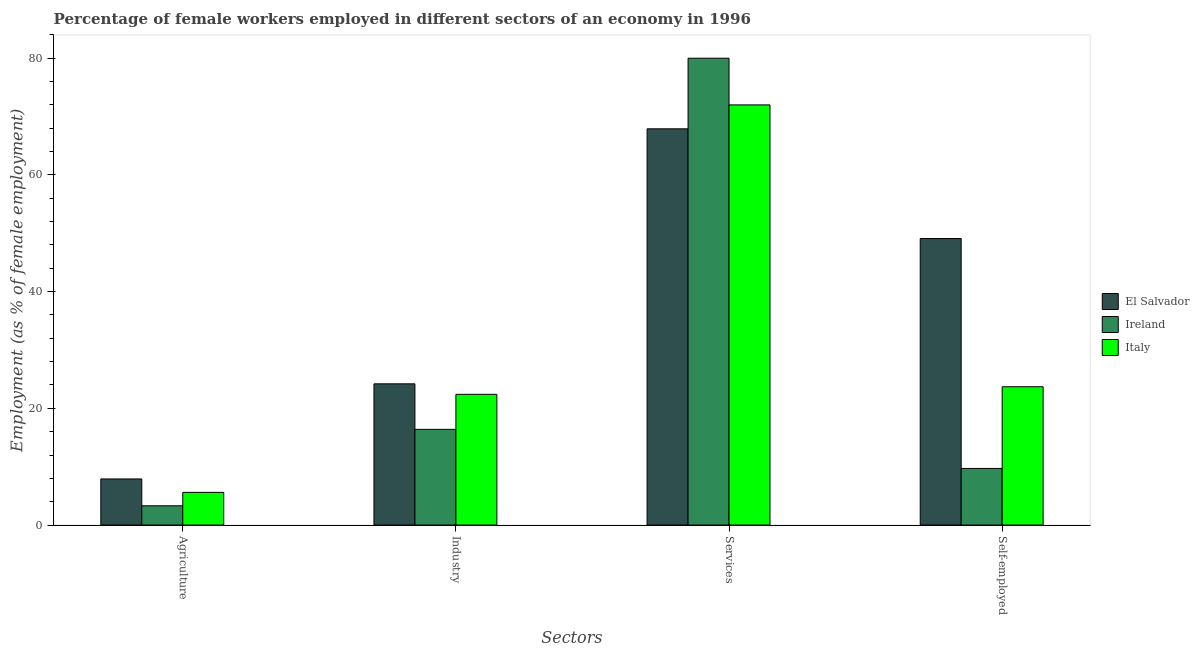How many different coloured bars are there?
Ensure brevity in your answer.  3. How many groups of bars are there?
Keep it short and to the point. 4. Are the number of bars per tick equal to the number of legend labels?
Your answer should be compact. Yes. How many bars are there on the 4th tick from the right?
Give a very brief answer. 3. What is the label of the 3rd group of bars from the left?
Your answer should be very brief. Services. What is the percentage of female workers in industry in Ireland?
Provide a succinct answer. 16.4. Across all countries, what is the maximum percentage of female workers in industry?
Your response must be concise. 24.2. Across all countries, what is the minimum percentage of female workers in services?
Provide a succinct answer. 67.9. In which country was the percentage of self employed female workers maximum?
Make the answer very short. El Salvador. In which country was the percentage of self employed female workers minimum?
Ensure brevity in your answer.  Ireland. What is the total percentage of female workers in services in the graph?
Provide a succinct answer. 219.9. What is the difference between the percentage of self employed female workers in Ireland and that in Italy?
Offer a very short reply. -14. What is the difference between the percentage of female workers in agriculture in Ireland and the percentage of self employed female workers in El Salvador?
Keep it short and to the point. -45.8. What is the average percentage of female workers in agriculture per country?
Your answer should be compact. 5.6. What is the difference between the percentage of female workers in agriculture and percentage of self employed female workers in El Salvador?
Keep it short and to the point. -41.2. What is the ratio of the percentage of self employed female workers in Ireland to that in El Salvador?
Keep it short and to the point. 0.2. Is the percentage of female workers in agriculture in Ireland less than that in Italy?
Your answer should be very brief. Yes. What is the difference between the highest and the second highest percentage of female workers in agriculture?
Provide a short and direct response. 2.3. What is the difference between the highest and the lowest percentage of female workers in agriculture?
Give a very brief answer. 4.6. Is the sum of the percentage of self employed female workers in Italy and El Salvador greater than the maximum percentage of female workers in industry across all countries?
Give a very brief answer. Yes. Is it the case that in every country, the sum of the percentage of female workers in agriculture and percentage of female workers in services is greater than the sum of percentage of female workers in industry and percentage of self employed female workers?
Your answer should be very brief. Yes. What does the 2nd bar from the left in Industry represents?
Provide a succinct answer. Ireland. How many bars are there?
Make the answer very short. 12. Are all the bars in the graph horizontal?
Your answer should be very brief. No. How many countries are there in the graph?
Ensure brevity in your answer.  3. Does the graph contain grids?
Make the answer very short. No. Where does the legend appear in the graph?
Keep it short and to the point. Center right. How many legend labels are there?
Ensure brevity in your answer.  3. What is the title of the graph?
Your answer should be very brief. Percentage of female workers employed in different sectors of an economy in 1996. Does "Sao Tome and Principe" appear as one of the legend labels in the graph?
Keep it short and to the point. No. What is the label or title of the X-axis?
Offer a very short reply. Sectors. What is the label or title of the Y-axis?
Your answer should be compact. Employment (as % of female employment). What is the Employment (as % of female employment) of El Salvador in Agriculture?
Your answer should be compact. 7.9. What is the Employment (as % of female employment) of Ireland in Agriculture?
Offer a very short reply. 3.3. What is the Employment (as % of female employment) of Italy in Agriculture?
Keep it short and to the point. 5.6. What is the Employment (as % of female employment) in El Salvador in Industry?
Your answer should be very brief. 24.2. What is the Employment (as % of female employment) of Ireland in Industry?
Your answer should be very brief. 16.4. What is the Employment (as % of female employment) of Italy in Industry?
Offer a terse response. 22.4. What is the Employment (as % of female employment) of El Salvador in Services?
Your answer should be compact. 67.9. What is the Employment (as % of female employment) in Italy in Services?
Provide a succinct answer. 72. What is the Employment (as % of female employment) in El Salvador in Self-employed?
Your answer should be very brief. 49.1. What is the Employment (as % of female employment) in Ireland in Self-employed?
Provide a succinct answer. 9.7. What is the Employment (as % of female employment) in Italy in Self-employed?
Make the answer very short. 23.7. Across all Sectors, what is the maximum Employment (as % of female employment) of El Salvador?
Your answer should be very brief. 67.9. Across all Sectors, what is the maximum Employment (as % of female employment) of Italy?
Provide a succinct answer. 72. Across all Sectors, what is the minimum Employment (as % of female employment) of El Salvador?
Give a very brief answer. 7.9. Across all Sectors, what is the minimum Employment (as % of female employment) of Ireland?
Ensure brevity in your answer.  3.3. Across all Sectors, what is the minimum Employment (as % of female employment) in Italy?
Provide a short and direct response. 5.6. What is the total Employment (as % of female employment) of El Salvador in the graph?
Keep it short and to the point. 149.1. What is the total Employment (as % of female employment) in Ireland in the graph?
Give a very brief answer. 109.4. What is the total Employment (as % of female employment) of Italy in the graph?
Offer a very short reply. 123.7. What is the difference between the Employment (as % of female employment) of El Salvador in Agriculture and that in Industry?
Offer a terse response. -16.3. What is the difference between the Employment (as % of female employment) of Ireland in Agriculture and that in Industry?
Your answer should be compact. -13.1. What is the difference between the Employment (as % of female employment) of Italy in Agriculture and that in Industry?
Your response must be concise. -16.8. What is the difference between the Employment (as % of female employment) in El Salvador in Agriculture and that in Services?
Give a very brief answer. -60. What is the difference between the Employment (as % of female employment) of Ireland in Agriculture and that in Services?
Offer a very short reply. -76.7. What is the difference between the Employment (as % of female employment) of Italy in Agriculture and that in Services?
Make the answer very short. -66.4. What is the difference between the Employment (as % of female employment) in El Salvador in Agriculture and that in Self-employed?
Offer a terse response. -41.2. What is the difference between the Employment (as % of female employment) of Italy in Agriculture and that in Self-employed?
Make the answer very short. -18.1. What is the difference between the Employment (as % of female employment) in El Salvador in Industry and that in Services?
Provide a short and direct response. -43.7. What is the difference between the Employment (as % of female employment) in Ireland in Industry and that in Services?
Offer a very short reply. -63.6. What is the difference between the Employment (as % of female employment) in Italy in Industry and that in Services?
Make the answer very short. -49.6. What is the difference between the Employment (as % of female employment) in El Salvador in Industry and that in Self-employed?
Your response must be concise. -24.9. What is the difference between the Employment (as % of female employment) in Ireland in Services and that in Self-employed?
Make the answer very short. 70.3. What is the difference between the Employment (as % of female employment) of Italy in Services and that in Self-employed?
Offer a terse response. 48.3. What is the difference between the Employment (as % of female employment) in El Salvador in Agriculture and the Employment (as % of female employment) in Ireland in Industry?
Provide a short and direct response. -8.5. What is the difference between the Employment (as % of female employment) of Ireland in Agriculture and the Employment (as % of female employment) of Italy in Industry?
Provide a short and direct response. -19.1. What is the difference between the Employment (as % of female employment) of El Salvador in Agriculture and the Employment (as % of female employment) of Ireland in Services?
Provide a short and direct response. -72.1. What is the difference between the Employment (as % of female employment) in El Salvador in Agriculture and the Employment (as % of female employment) in Italy in Services?
Provide a succinct answer. -64.1. What is the difference between the Employment (as % of female employment) in Ireland in Agriculture and the Employment (as % of female employment) in Italy in Services?
Make the answer very short. -68.7. What is the difference between the Employment (as % of female employment) in El Salvador in Agriculture and the Employment (as % of female employment) in Italy in Self-employed?
Your answer should be compact. -15.8. What is the difference between the Employment (as % of female employment) in Ireland in Agriculture and the Employment (as % of female employment) in Italy in Self-employed?
Your answer should be compact. -20.4. What is the difference between the Employment (as % of female employment) of El Salvador in Industry and the Employment (as % of female employment) of Ireland in Services?
Provide a succinct answer. -55.8. What is the difference between the Employment (as % of female employment) of El Salvador in Industry and the Employment (as % of female employment) of Italy in Services?
Keep it short and to the point. -47.8. What is the difference between the Employment (as % of female employment) in Ireland in Industry and the Employment (as % of female employment) in Italy in Services?
Your response must be concise. -55.6. What is the difference between the Employment (as % of female employment) of El Salvador in Industry and the Employment (as % of female employment) of Italy in Self-employed?
Offer a terse response. 0.5. What is the difference between the Employment (as % of female employment) in El Salvador in Services and the Employment (as % of female employment) in Ireland in Self-employed?
Your answer should be very brief. 58.2. What is the difference between the Employment (as % of female employment) in El Salvador in Services and the Employment (as % of female employment) in Italy in Self-employed?
Keep it short and to the point. 44.2. What is the difference between the Employment (as % of female employment) of Ireland in Services and the Employment (as % of female employment) of Italy in Self-employed?
Offer a terse response. 56.3. What is the average Employment (as % of female employment) in El Salvador per Sectors?
Provide a succinct answer. 37.27. What is the average Employment (as % of female employment) in Ireland per Sectors?
Make the answer very short. 27.35. What is the average Employment (as % of female employment) in Italy per Sectors?
Make the answer very short. 30.93. What is the difference between the Employment (as % of female employment) in Ireland and Employment (as % of female employment) in Italy in Agriculture?
Your answer should be very brief. -2.3. What is the difference between the Employment (as % of female employment) in El Salvador and Employment (as % of female employment) in Italy in Industry?
Make the answer very short. 1.8. What is the difference between the Employment (as % of female employment) of El Salvador and Employment (as % of female employment) of Ireland in Services?
Your response must be concise. -12.1. What is the difference between the Employment (as % of female employment) of Ireland and Employment (as % of female employment) of Italy in Services?
Your answer should be very brief. 8. What is the difference between the Employment (as % of female employment) in El Salvador and Employment (as % of female employment) in Ireland in Self-employed?
Provide a succinct answer. 39.4. What is the difference between the Employment (as % of female employment) of El Salvador and Employment (as % of female employment) of Italy in Self-employed?
Offer a very short reply. 25.4. What is the ratio of the Employment (as % of female employment) in El Salvador in Agriculture to that in Industry?
Provide a short and direct response. 0.33. What is the ratio of the Employment (as % of female employment) of Ireland in Agriculture to that in Industry?
Keep it short and to the point. 0.2. What is the ratio of the Employment (as % of female employment) of Italy in Agriculture to that in Industry?
Your response must be concise. 0.25. What is the ratio of the Employment (as % of female employment) of El Salvador in Agriculture to that in Services?
Give a very brief answer. 0.12. What is the ratio of the Employment (as % of female employment) in Ireland in Agriculture to that in Services?
Give a very brief answer. 0.04. What is the ratio of the Employment (as % of female employment) of Italy in Agriculture to that in Services?
Provide a succinct answer. 0.08. What is the ratio of the Employment (as % of female employment) in El Salvador in Agriculture to that in Self-employed?
Make the answer very short. 0.16. What is the ratio of the Employment (as % of female employment) in Ireland in Agriculture to that in Self-employed?
Provide a succinct answer. 0.34. What is the ratio of the Employment (as % of female employment) in Italy in Agriculture to that in Self-employed?
Provide a succinct answer. 0.24. What is the ratio of the Employment (as % of female employment) of El Salvador in Industry to that in Services?
Your response must be concise. 0.36. What is the ratio of the Employment (as % of female employment) of Ireland in Industry to that in Services?
Provide a succinct answer. 0.2. What is the ratio of the Employment (as % of female employment) in Italy in Industry to that in Services?
Offer a very short reply. 0.31. What is the ratio of the Employment (as % of female employment) of El Salvador in Industry to that in Self-employed?
Offer a very short reply. 0.49. What is the ratio of the Employment (as % of female employment) of Ireland in Industry to that in Self-employed?
Make the answer very short. 1.69. What is the ratio of the Employment (as % of female employment) of Italy in Industry to that in Self-employed?
Keep it short and to the point. 0.95. What is the ratio of the Employment (as % of female employment) of El Salvador in Services to that in Self-employed?
Keep it short and to the point. 1.38. What is the ratio of the Employment (as % of female employment) of Ireland in Services to that in Self-employed?
Your answer should be very brief. 8.25. What is the ratio of the Employment (as % of female employment) in Italy in Services to that in Self-employed?
Provide a succinct answer. 3.04. What is the difference between the highest and the second highest Employment (as % of female employment) of El Salvador?
Give a very brief answer. 18.8. What is the difference between the highest and the second highest Employment (as % of female employment) in Ireland?
Keep it short and to the point. 63.6. What is the difference between the highest and the second highest Employment (as % of female employment) in Italy?
Offer a very short reply. 48.3. What is the difference between the highest and the lowest Employment (as % of female employment) in Ireland?
Offer a very short reply. 76.7. What is the difference between the highest and the lowest Employment (as % of female employment) of Italy?
Your answer should be very brief. 66.4. 